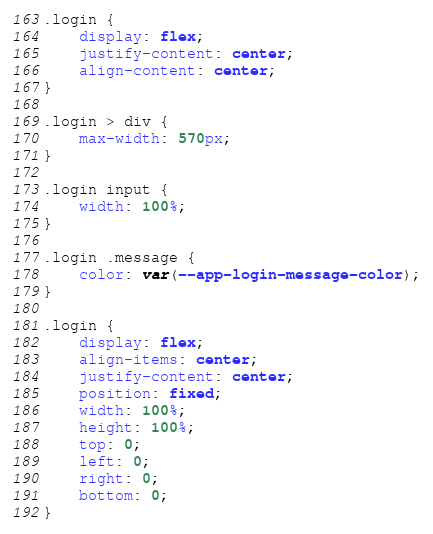<code> <loc_0><loc_0><loc_500><loc_500><_CSS_>.login {
    display: flex;
    justify-content: center;
    align-content: center;
}

.login > div {
    max-width: 570px;
}

.login input {
    width: 100%;
}

.login .message {
    color: var(--app-login-message-color);
}

.login {
    display: flex;
    align-items: center;
    justify-content: center;
    position: fixed;
    width: 100%;
    height: 100%;
    top: 0;
    left: 0;
    right: 0;
    bottom: 0;
}
</code> 